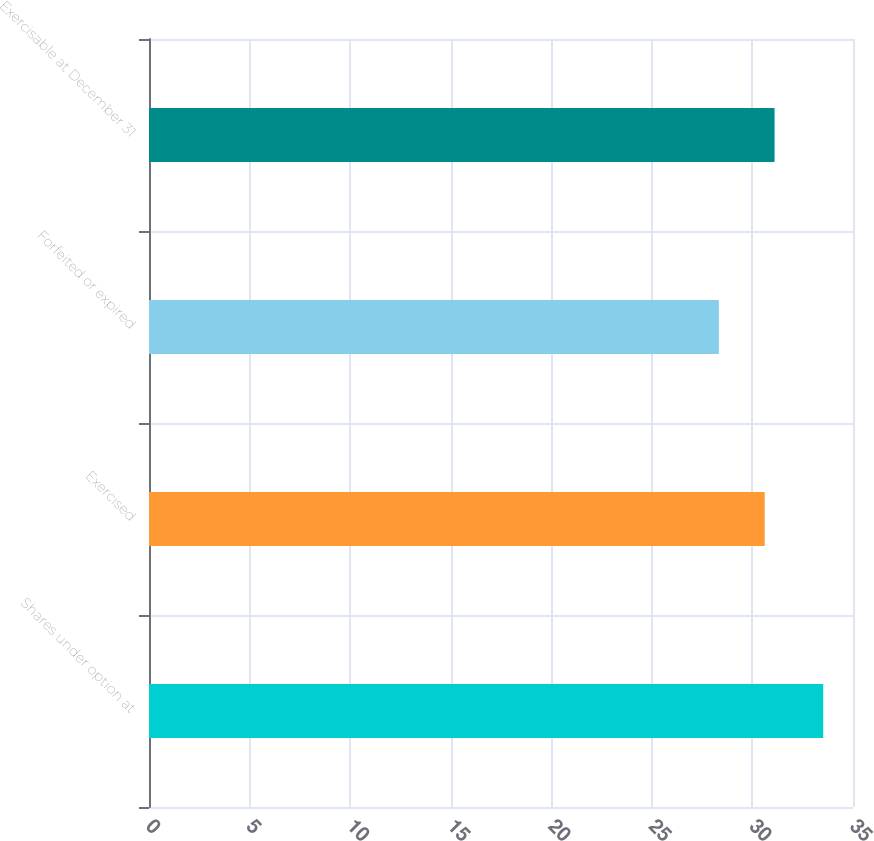Convert chart to OTSL. <chart><loc_0><loc_0><loc_500><loc_500><bar_chart><fcel>Shares under option at<fcel>Exercised<fcel>Forfeited or expired<fcel>Exercisable at December 31<nl><fcel>33.52<fcel>30.61<fcel>28.33<fcel>31.1<nl></chart> 